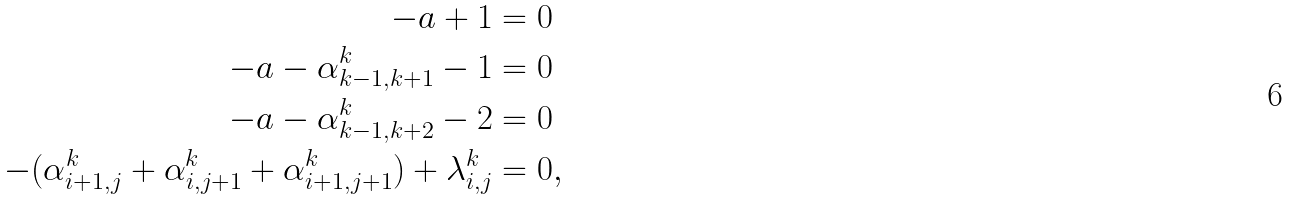Convert formula to latex. <formula><loc_0><loc_0><loc_500><loc_500>- a + 1 & = 0 \\ - a - \alpha _ { k - 1 , k + 1 } ^ { k } - 1 & = 0 \\ - a - \alpha _ { k - 1 , k + 2 } ^ { k } - 2 & = 0 \\ - ( \alpha _ { i + 1 , j } ^ { k } + \alpha _ { i , j + 1 } ^ { k } + \alpha _ { i + 1 , j + 1 } ^ { k } ) + \lambda _ { i , j } ^ { k } & = 0 ,</formula> 